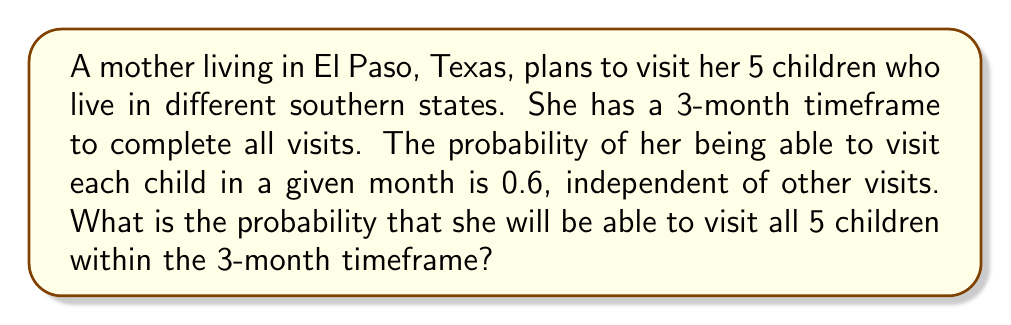Provide a solution to this math problem. Let's approach this step-by-step:

1) For each child, the probability of not visiting in a given month is $1 - 0.6 = 0.4$.

2) The probability of not visiting a specific child in all 3 months is:
   $$(0.4)^3 = 0.064$$

3) Therefore, the probability of visiting a specific child at least once in 3 months is:
   $$1 - (0.4)^3 = 0.936$$

4) For the mother to visit all 5 children, she needs to succeed in visiting each child at least once. Since the visits are independent, we multiply the individual probabilities:
   $$(0.936)^5$$

5) Calculate the final probability:
   $$\begin{align}
   (0.936)^5 &= 0.936 \times 0.936 \times 0.936 \times 0.936 \times 0.936 \\
   &\approx 0.7190
   \end{align}$$
Answer: The probability that the mother will be able to visit all 5 children within the 3-month timeframe is approximately 0.7190 or 71.90%. 